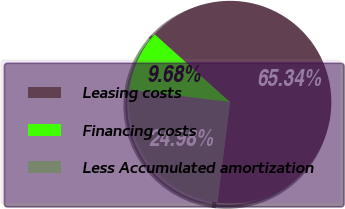<chart> <loc_0><loc_0><loc_500><loc_500><pie_chart><fcel>Leasing costs<fcel>Financing costs<fcel>Less Accumulated amortization<nl><fcel>65.34%<fcel>9.68%<fcel>24.98%<nl></chart> 